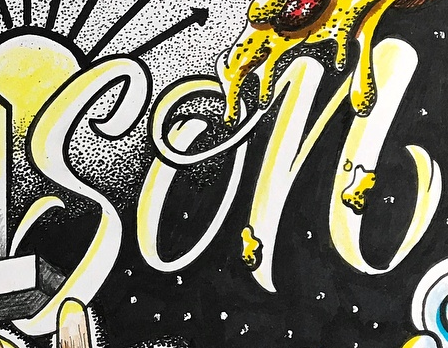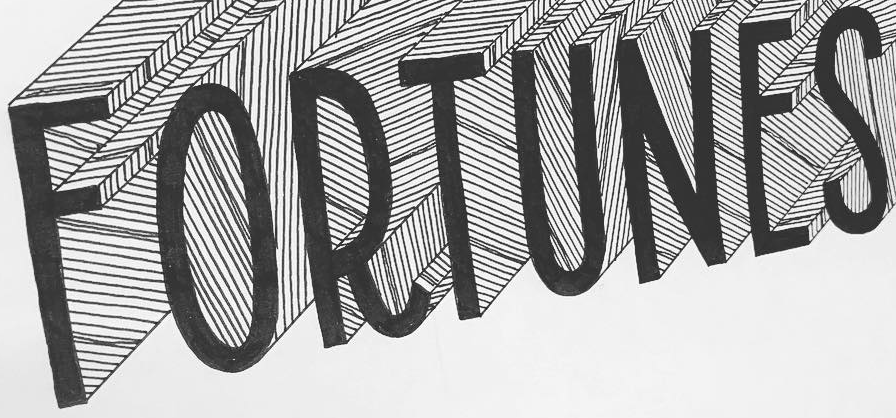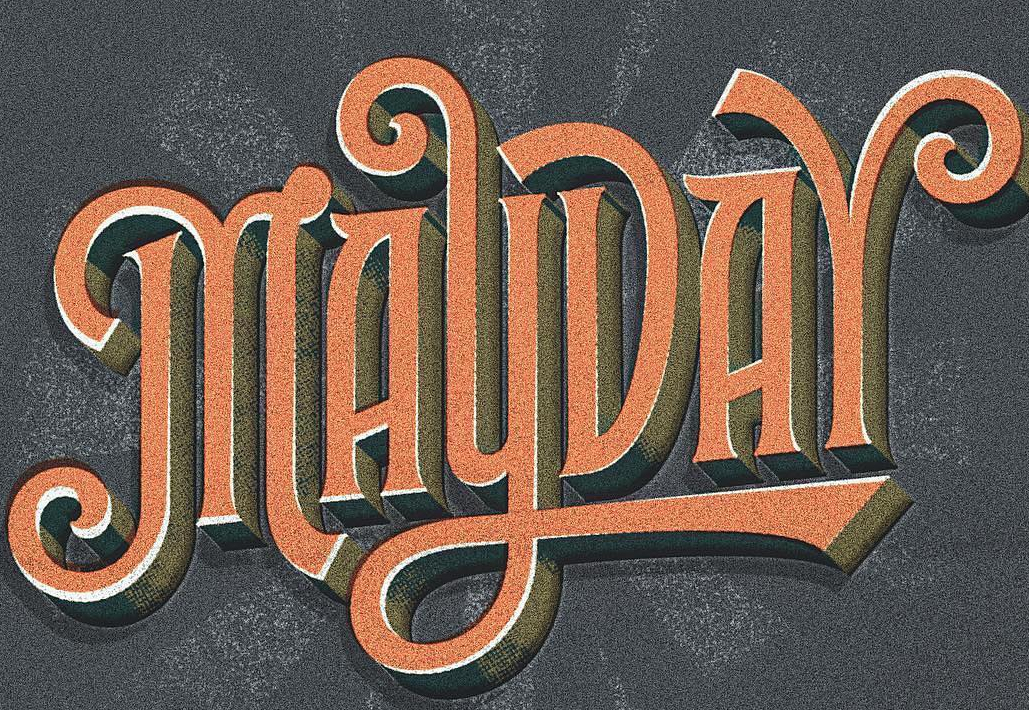What text appears in these images from left to right, separated by a semicolon? son; FORTUNES; MAYDAY 